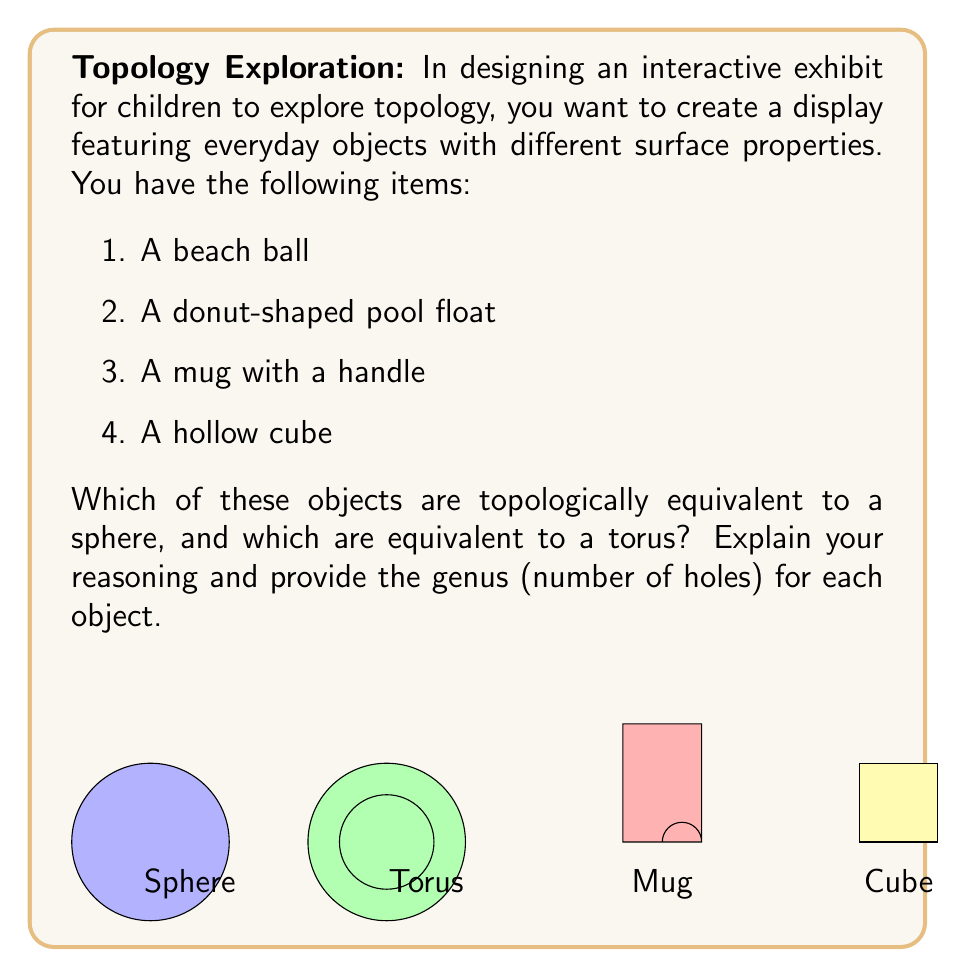Help me with this question. Let's analyze each object step-by-step:

1. Beach ball:
   - A beach ball is topologically equivalent to a sphere.
   - It has no holes, so its genus is 0.
   - Mathematically, we can express this as $g = 0$, where $g$ is the genus.

2. Donut-shaped pool float:
   - This object is topologically equivalent to a torus.
   - It has one hole (the center of the donut), so its genus is 1.
   - Mathematically, $g = 1$.

3. Mug with a handle:
   - A mug with a handle is also topologically equivalent to a torus.
   - The handle creates one hole, giving it a genus of 1.
   - Mathematically, $g = 1$.

4. Hollow cube:
   - A hollow cube is topologically equivalent to a sphere.
   - It has no holes (the inside doesn't count as a topological hole), so its genus is 0.
   - Mathematically, $g = 0$.

In topology, two objects are considered equivalent if one can be continuously deformed into the other without cutting or gluing. The genus is a topological invariant, meaning it doesn't change under continuous deformations.

The beach ball and hollow cube can be continuously deformed into each other and into a sphere, so they are topologically equivalent. Their genus of 0 confirms this.

The donut-shaped pool float and the mug with a handle can be continuously deformed into each other and into a torus. Their genus of 1 confirms this topological equivalence.

To summarize:
- Sphere-equivalent (genus 0): Beach ball, Hollow cube
- Torus-equivalent (genus 1): Donut-shaped pool float, Mug with a handle
Answer: Sphere-equivalent: Beach ball, Hollow cube (genus 0)
Torus-equivalent: Donut-shaped pool float, Mug with handle (genus 1) 